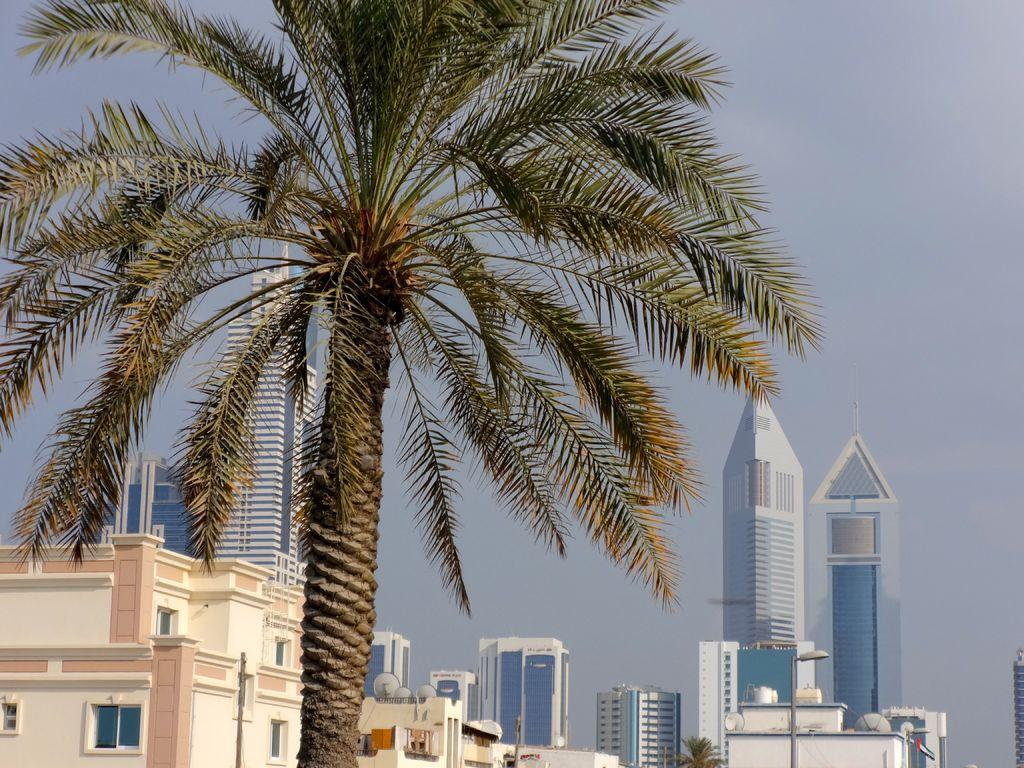What type of natural element is present in the image? There is a tree in the image. What can be seen in the distance in the image? There are buildings, windows, dish antennas, light poles, and the sky visible in the background of the image. What type of veil is draped over the tree in the image? There is no veil present in the image; it is just a tree with no additional coverings. Can you see any fish swimming in the sky in the image? There are no fish visible in the sky in the image; only the sky and other background elements can be seen. 